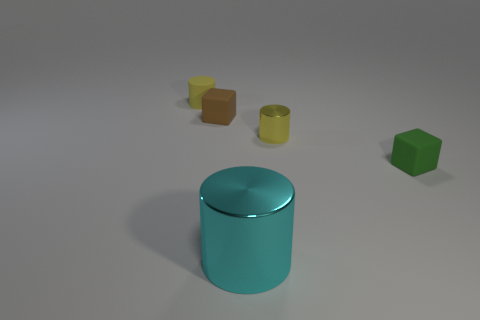Add 1 green things. How many objects exist? 6 Subtract all cubes. How many objects are left? 3 Add 3 yellow rubber things. How many yellow rubber things are left? 4 Add 5 big red matte objects. How many big red matte objects exist? 5 Subtract 0 brown cylinders. How many objects are left? 5 Subtract all brown matte objects. Subtract all brown matte cylinders. How many objects are left? 4 